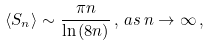Convert formula to latex. <formula><loc_0><loc_0><loc_500><loc_500>\langle S _ { n } \rangle \sim \frac { \pi n } { \ln { ( 8 n ) } } \, , \, a s \, n \rightarrow \infty \, ,</formula> 